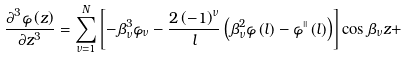<formula> <loc_0><loc_0><loc_500><loc_500>\frac { \partial ^ { 3 } \varphi \left ( z \right ) } { \partial z ^ { 3 } } = \sum _ { \nu = 1 } ^ { N } \left [ - \beta _ { \nu } ^ { 3 } \varphi _ { \nu } - \frac { 2 \left ( - 1 \right ) ^ { \nu } } { l } \left ( \beta _ { \nu } ^ { 2 } \varphi \left ( l \right ) - \varphi ^ { \shortmid \shortmid } \left ( l \right ) \right ) \right ] \cos \beta _ { \nu } z +</formula> 